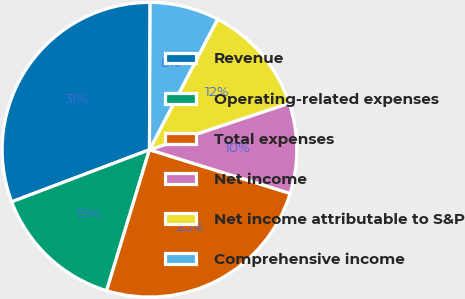<chart> <loc_0><loc_0><loc_500><loc_500><pie_chart><fcel>Revenue<fcel>Operating-related expenses<fcel>Total expenses<fcel>Net income<fcel>Net income attributable to S&P<fcel>Comprehensive income<nl><fcel>30.82%<fcel>14.55%<fcel>24.91%<fcel>9.91%<fcel>12.23%<fcel>7.58%<nl></chart> 